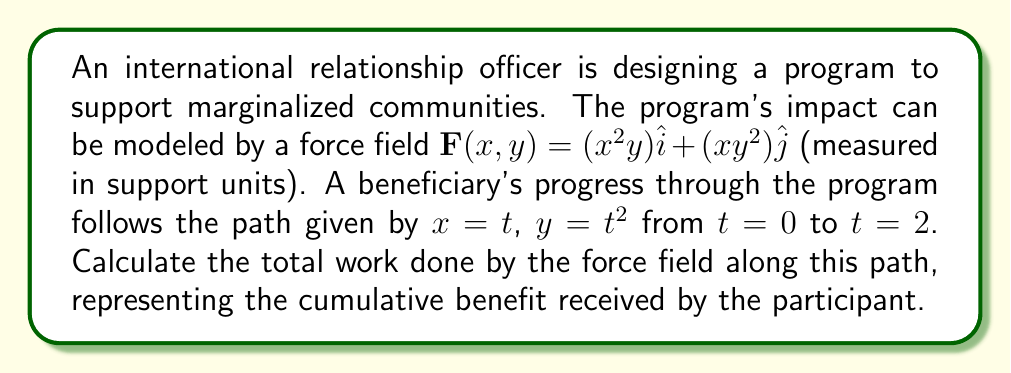Could you help me with this problem? To calculate the work done by a variable force field along a curved path, we need to use the line integral:

$$W = \int_C \mathbf{F} \cdot d\mathbf{r}$$

Where $\mathbf{F}$ is the force field and $d\mathbf{r}$ is the differential displacement vector along the path.

1) First, let's parameterize the path:
   $x = t$, $y = t^2$, $0 \leq t \leq 2$

2) The differential displacement vector is:
   $d\mathbf{r} = dx\hat{i} + dy\hat{j} = dt\hat{i} + 2tdt\hat{j}$

3) Substitute the path equations into the force field:
   $\mathbf{F}(t) = (t^2(t^2))\hat{i} + (t(t^2)^2)\hat{j} = t^4\hat{i} + t^5\hat{j}$

4) Now, we can set up the line integral:
   $$W = \int_0^2 (t^4\hat{i} + t^5\hat{j}) \cdot (dt\hat{i} + 2tdt\hat{j})$$

5) Expand the dot product:
   $$W = \int_0^2 (t^4dt + 2t^6dt)$$

6) Simplify:
   $$W = \int_0^2 (t^4 + 2t^6)dt$$

7) Integrate:
   $$W = \left[\frac{t^5}{5} + \frac{2t^7}{7}\right]_0^2$$

8) Evaluate the limits:
   $$W = \left(\frac{2^5}{5} + \frac{2(2^7)}{7}\right) - \left(0 + 0\right)$$

9) Calculate the final result:
   $$W = \frac{32}{5} + \frac{256}{7} = 6.4 + 36.57 = 42.97$$
Answer: The total work done by the force field along the path is approximately 42.97 support units. 